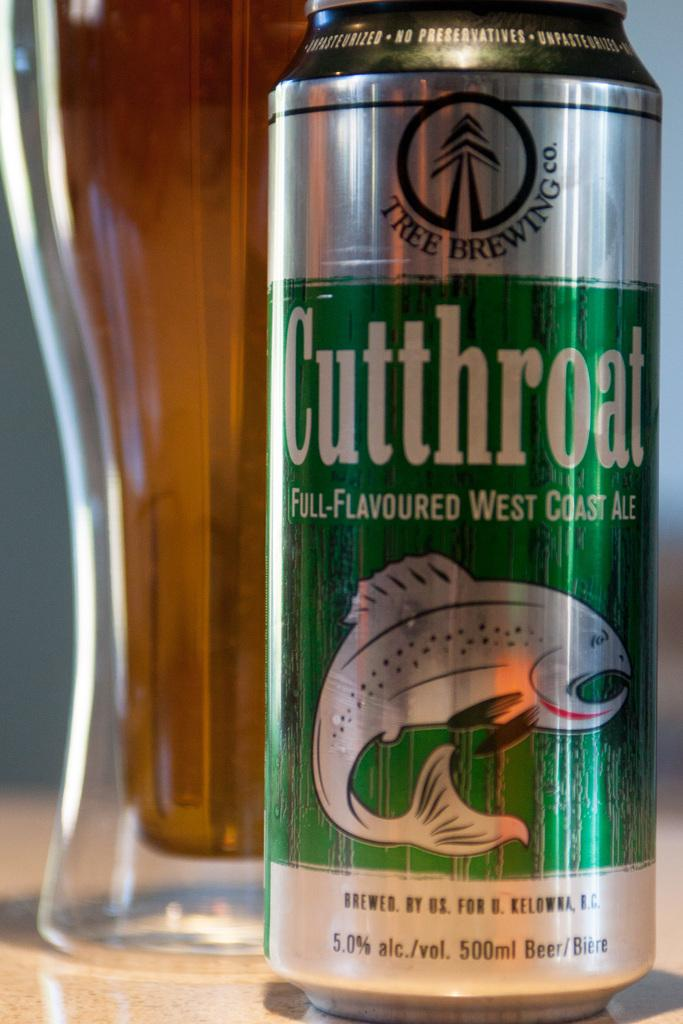<image>
Provide a brief description of the given image. one can of beer that read cutthroat and behind the beer can is a glass full of beer 